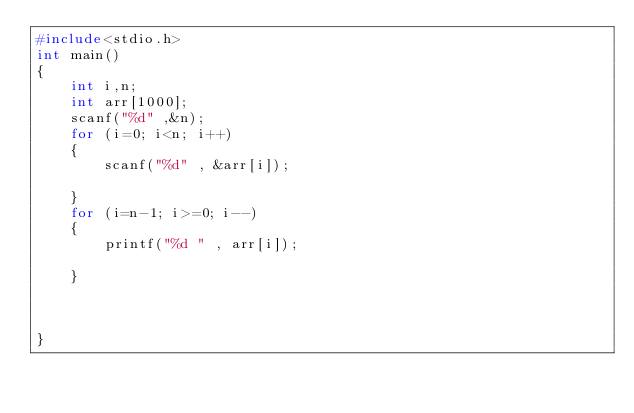<code> <loc_0><loc_0><loc_500><loc_500><_C_>#include<stdio.h>
int main()
{
    int i,n;
    int arr[1000];
    scanf("%d" ,&n);
    for (i=0; i<n; i++)
    {
        scanf("%d" , &arr[i]);
        
    }
    for (i=n-1; i>=0; i--)
    {
        printf("%d " , arr[i]);
        
    }


    
}</code> 